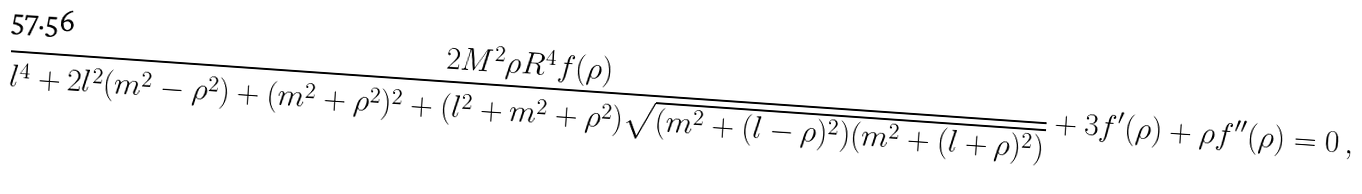Convert formula to latex. <formula><loc_0><loc_0><loc_500><loc_500>\frac { 2 M ^ { 2 } \rho R ^ { 4 } f ( \rho ) } { l ^ { 4 } + 2 l ^ { 2 } ( m ^ { 2 } - \rho ^ { 2 } ) + ( m ^ { 2 } + \rho ^ { 2 } ) ^ { 2 } + ( l ^ { 2 } + m ^ { 2 } + \rho ^ { 2 } ) \sqrt { ( m ^ { 2 } + ( l - \rho ) ^ { 2 } ) ( m ^ { 2 } + ( l + \rho ) ^ { 2 } ) } } + 3 f ^ { \prime } ( \rho ) + \rho f ^ { \prime \prime } ( \rho ) = 0 \ ,</formula> 